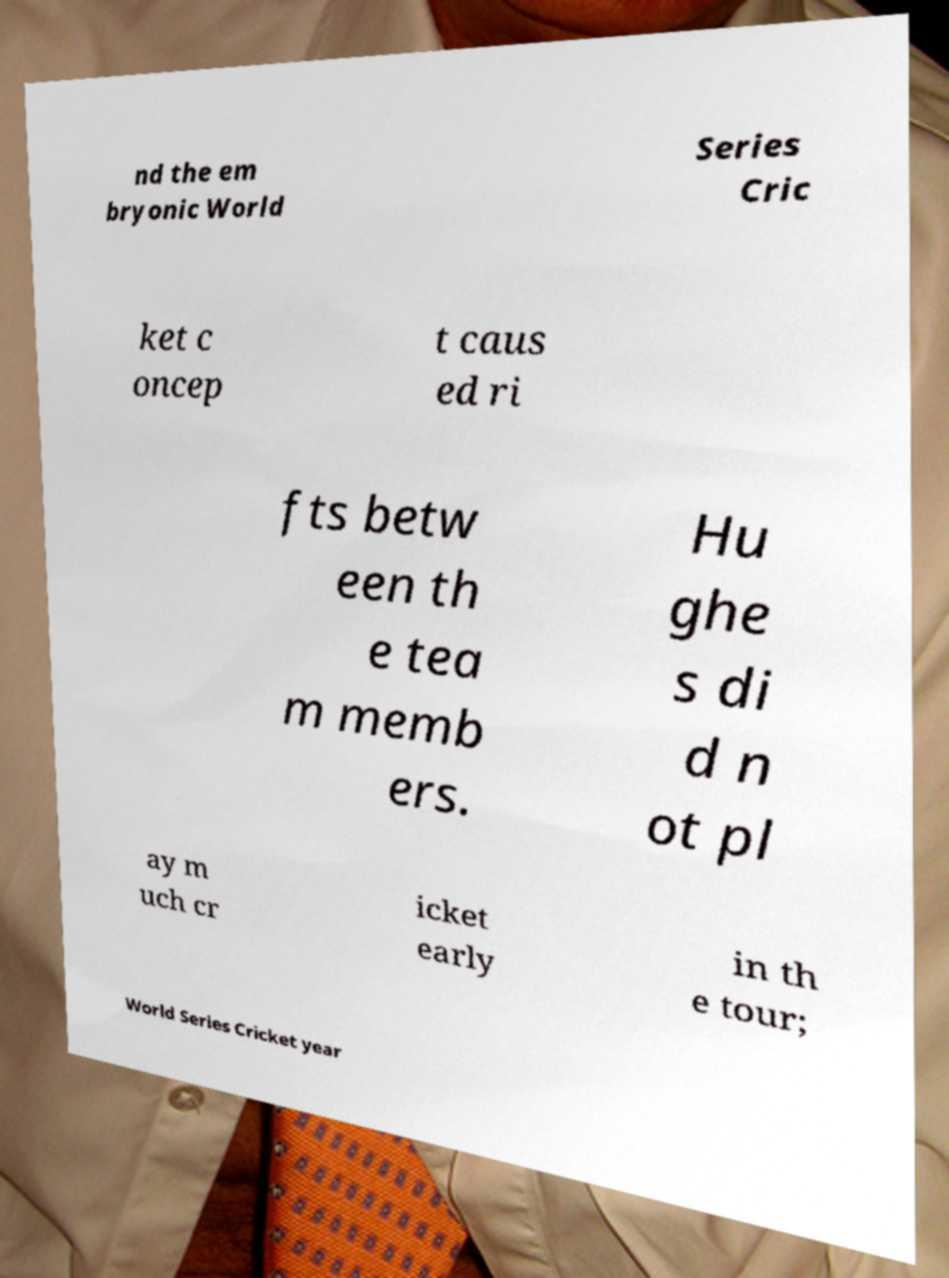Can you accurately transcribe the text from the provided image for me? nd the em bryonic World Series Cric ket c oncep t caus ed ri fts betw een th e tea m memb ers. Hu ghe s di d n ot pl ay m uch cr icket early in th e tour; World Series Cricket year 